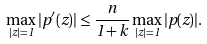<formula> <loc_0><loc_0><loc_500><loc_500>\max _ { | z | = 1 } | p ^ { \prime } ( z ) | \leq \frac { n } { 1 + k } \max _ { | z | = 1 } | p ( z ) | .</formula> 